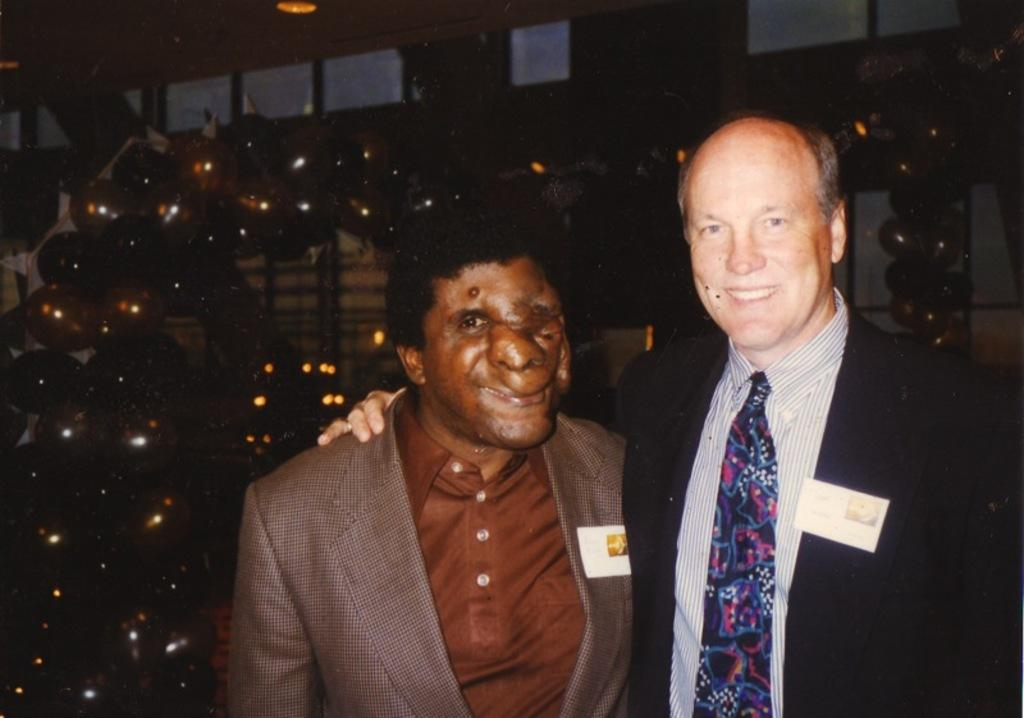How many people are in the image? There are two persons in the image. What are the persons wearing? The persons are wearing suits. What expression do the persons have? The persons are smiling. What position are the persons in? The persons are standing. What can be seen in the background of the image? There are lights, balloons, and other objects visible in the background of the image. What type of muscle is visible on the persons' arms in the image? There is no visible muscle on the persons' arms in the image; they are wearing suits that cover their arms. 